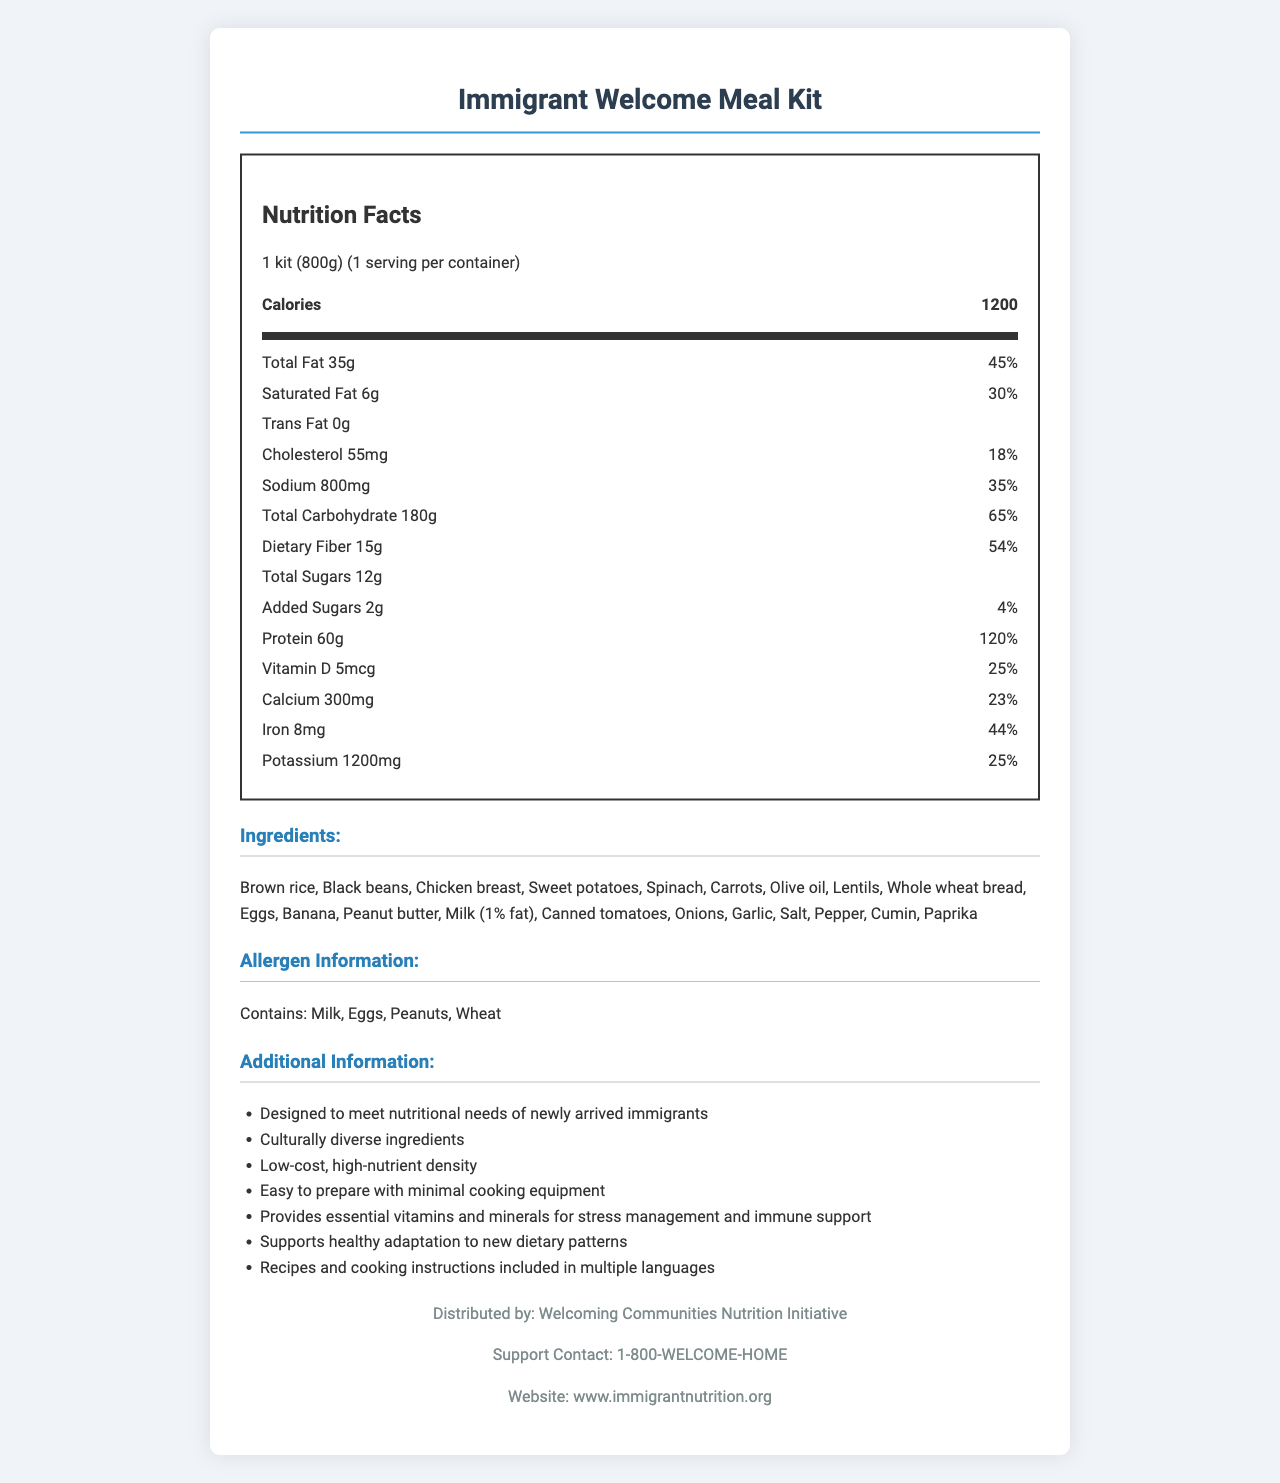what is the product name? The name at the top of the document reads "Immigrant Welcome Meal Kit".
Answer: Immigrant Welcome Meal Kit what is the serving size? The document states that the serving size is "1 kit (800g)".
Answer: 1 kit (800g) how many calories does one serving contain? Under the "Nutrition Facts" section, the calories are listed as 1200.
Answer: 1200 what are the ingredients of this meal kit? The document lists all these ingredients under the Ingredients section.
Answer: Brown rice, Black beans, Chicken breast, Sweet potatoes, Spinach, Carrots, Olive oil, Lentils, Whole wheat bread, Eggs, Banana, Peanut butter, Milk (1% fat), Canned tomatoes, Onions, Garlic, Salt, Pepper, Cumin, Paprika what vitamins and minerals are included and their daily value percentages? The "Nutrition Facts" section lists the daily value percentages for these vitamins and minerals.
Answer: Vitamin D 25%, Calcium 23%, Iron 44%, Potassium 25% what is the amount of protein in the meal kit? The amount of protein is 60g as listed in the Nutrition Facts section.
Answer: 60g what type of information is included in the additional info section? The Additional Information section lists a detailed set of benefits and features about the meal kit.
Answer: Designed to meet nutritional needs of newly arrived immigrants, Culturally diverse ingredients, Low-cost, high-nutrient density, Easy to prepare with minimal cooking equipment, Provides essential vitamins and minerals for stress management and immune support, Supports healthy adaptation to new dietary patterns, Recipes and cooking instructions included in multiple languages how much saturated fat does the meal kit contain? The saturated fat content is listed as 6g in the Nutrition Facts section.
Answer: 6g which allergens are present in the product? The Allergen Information section lists these allergens.
Answer: Milk, Eggs, Peanuts, Wheat what is the main purpose of distributing this meal kit? The document mentions that the meal kit is designed to meet the nutritional needs of newly arrived immigrants and is low-cost and high-nutrient density.
Answer: To provide a cost-effective, nutrient-dense meal plan for newly arrived immigrants with limited resources. which organization distributes this meal kit? The footer of the document states that it is distributed by the Welcoming Communities Nutrition Initiative.
Answer: Welcoming Communities Nutrition Initiative how much of the product contributes to the daily value of total fat? A. 30% B. 35% C. 45% D. 55% The document states that the total fat contributes 45% to the daily value.
Answer: C what is the dietary fiber content in one serving? A. 35g B. 54g C. 15g D. 45g The dietary fiber content is listed as 15g.
Answer: C does the document provide any recipes and cooking instructions? The Additional Information section mentions that recipes and cooking instructions are included in multiple languages.
Answer: Yes is there any information about the cost of the meal kit? The document does not provide any details about the cost of the meal kit.
Answer: Not enough information what is the main idea of this document? The document primarily focuses on offering all necessary information about the Immigrant Welcome Meal Kit, emphasizing its nutritional benefits and usefulness for newly arrived immigrants.
Answer: The document provides nutrition facts, ingredients, allergen information, and additional details for the Immigrant Welcome Meal Kit, which is designed to provide nutrient-dense, culturally diverse, and easy-to-prepare meals for newly arrived immigrants with limited resources. what contact information is provided for support? The Support Contact and Website sections at the bottom of the document provide this information.
Answer: 1-800-WELCOME-HOME, www.immigrantnutrition.org 